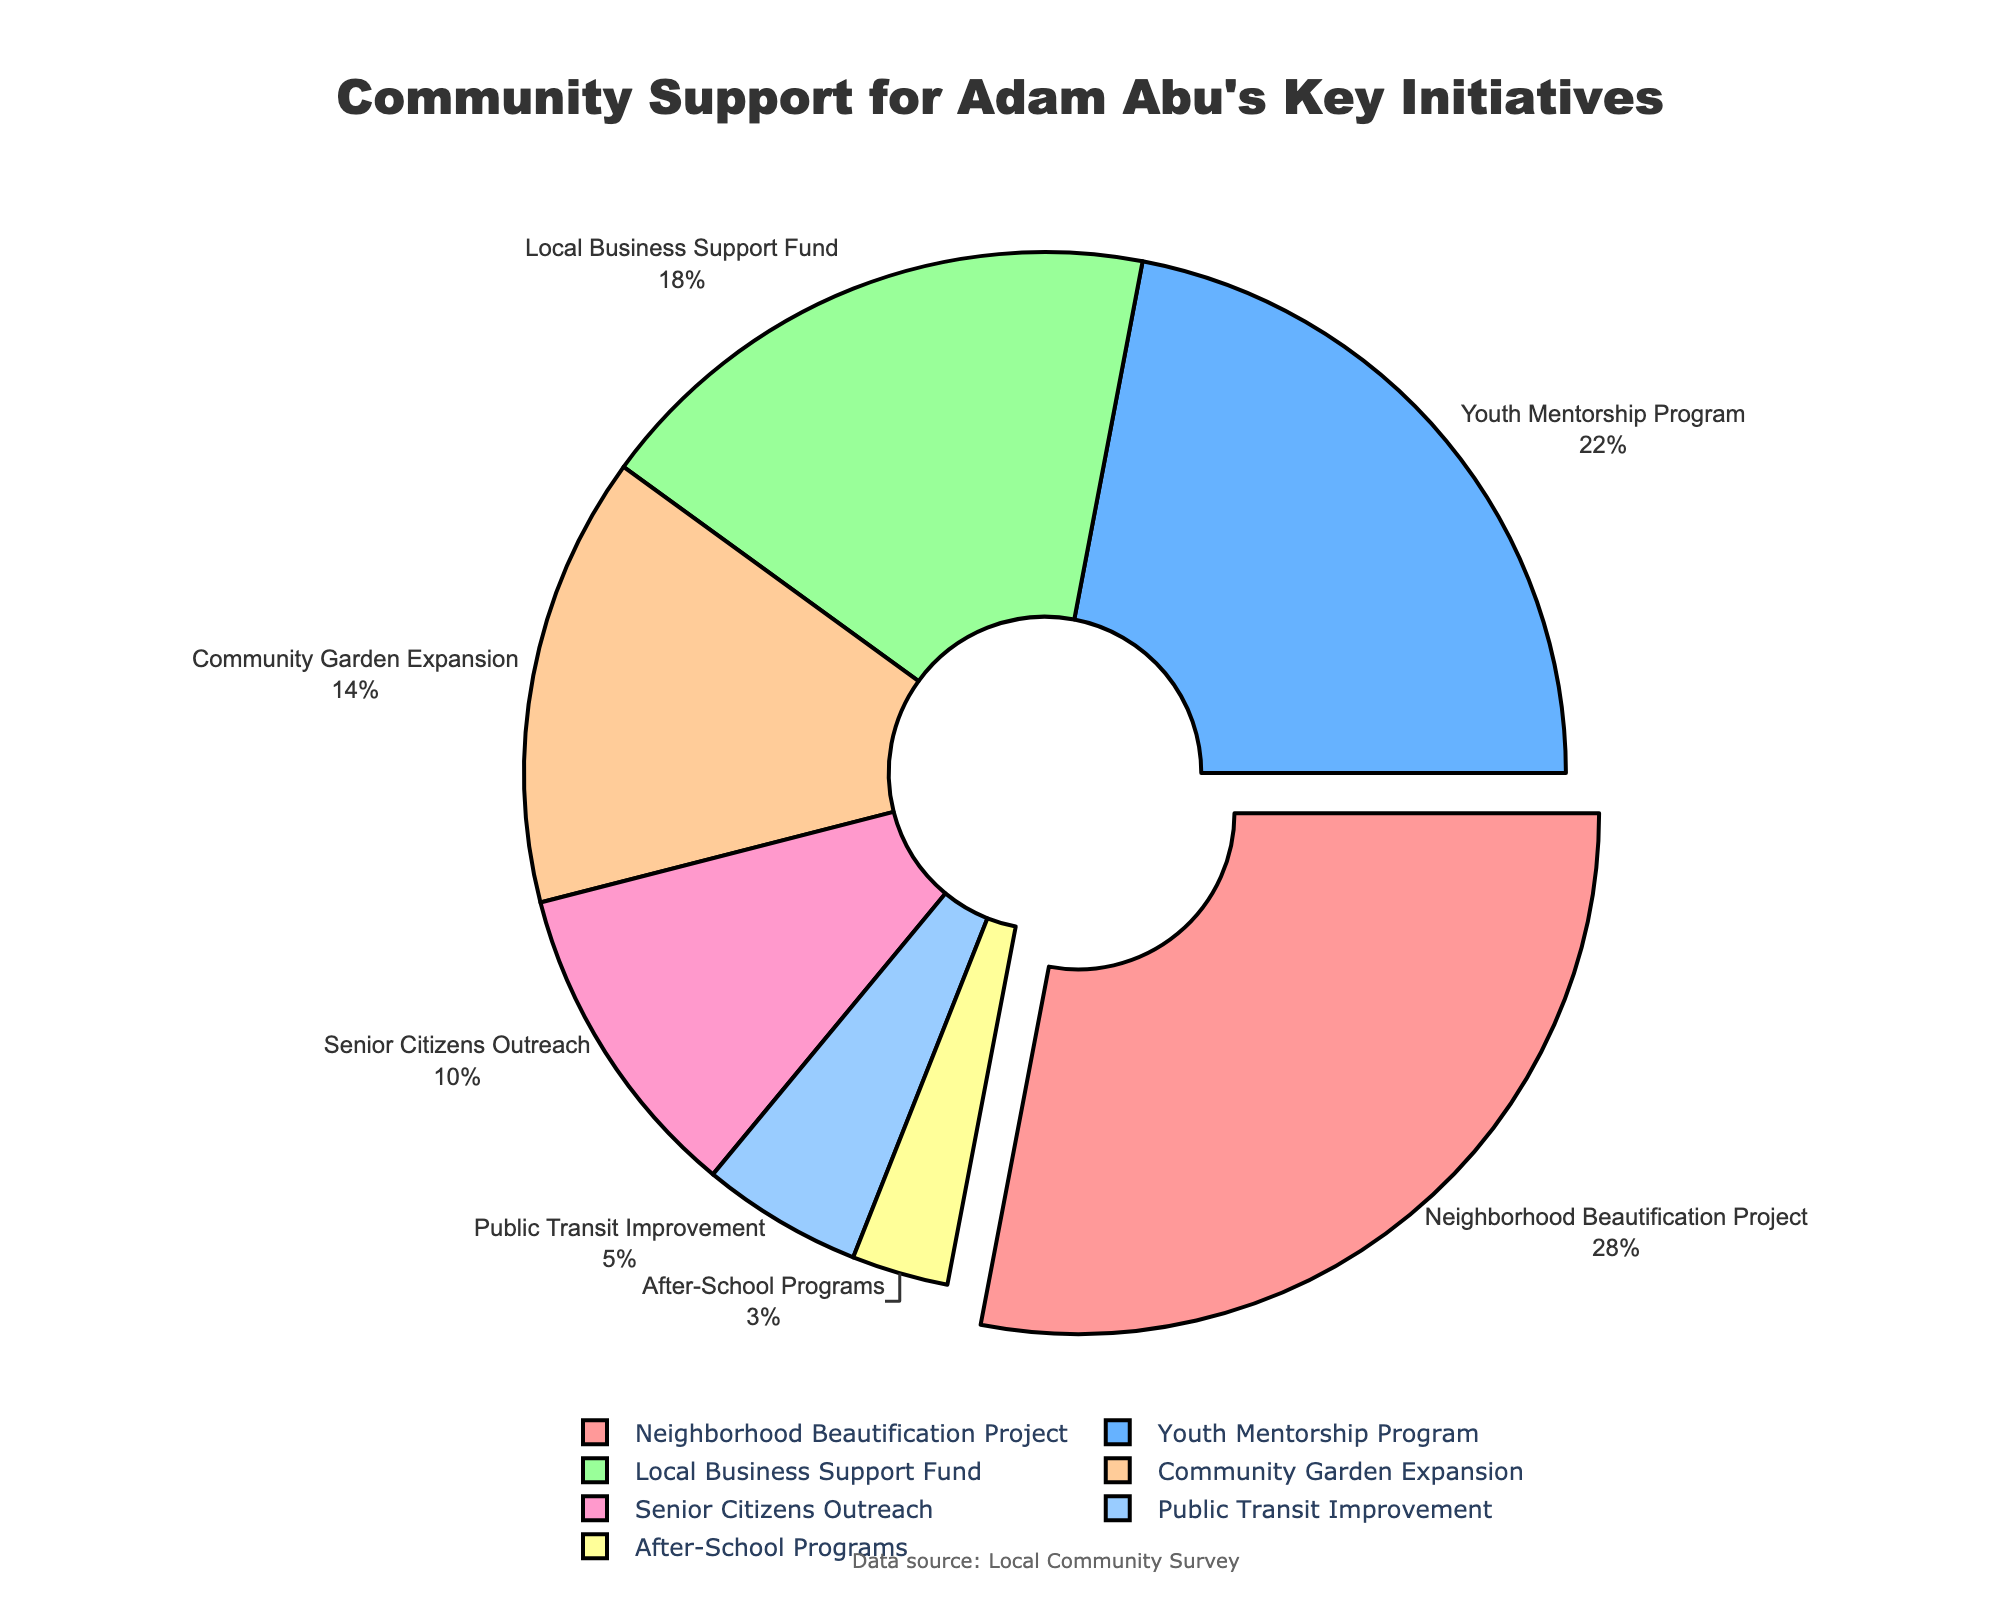Which initiative receives the most community support? The initiative labeled with the highest percentage on the pie chart is the "Neighborhood Beautification Project" with 28%.
Answer: Neighborhood Beautification Project What is the total percentage of support for the Youth Mentorship Program and Local Business Support Fund combined? Add the percentages for these two initiatives: 22% (Youth Mentorship Program) + 18% (Local Business Support Fund) = 40%.
Answer: 40% Which initiative has the least community support? The initiative labeled with the lowest percentage on the pie chart is "After-School Programs" with 3%.
Answer: After-School Programs Which initiatives together constitute at least 50% of the community support? The sum of the percentages of initiatives ordered from largest to smallest until the total reaches at least 50%: "Neighborhood Beautification Project" (28%) + "Youth Mentorship Program" (22%) = 50%.
Answer: Neighborhood Beautification Project, Youth Mentorship Program By how much does the community support for Community Garden Expansion exceed that for Public Transit Improvement? Subtract the percentage for Public Transit Improvement from that of Community Garden Expansion: 14% - 5% = 9%.
Answer: 9% Which initiative is represented by a purple slice in the pie chart? By observing the pie chart, the initiative represented by a purple slice is most likely the "Senior Citizens Outreach."
Answer: Senior Citizens Outreach What is the combined community support percentage for local business and senior outreach initiatives? Add the percentages for the Local Business Support Fund and Senior Citizens Outreach: 18% + 10% = 28%.
Answer: 28% Which initiatives receive exactly twice as much support compared to Public Transit Improvement? Identify initiatives where the percentage is twice 5% (Public Transit Improvement). These are the Community Garden Expansion (14%) which is close but slightly less and Youth Mentorship Program (22%) which is close but slightly more.
Answer: None exactly, but close ones are Youth Mentorship Program and Community Garden Expansion What percentage of the pie chart is dedicated to initiatives focused on youth? Add the percentages of Youth Mentorship Program (22%) and After-School Programs (3%): 22% + 3% = 25%.
Answer: 25% What is the average community support percentage across all initiatives? Add all the percentages and divide by the number of initiatives: (28 + 22 + 18 + 14 + 10 + 5 + 3) / 7 ≈ 14.29%.
Answer: 14.29% 